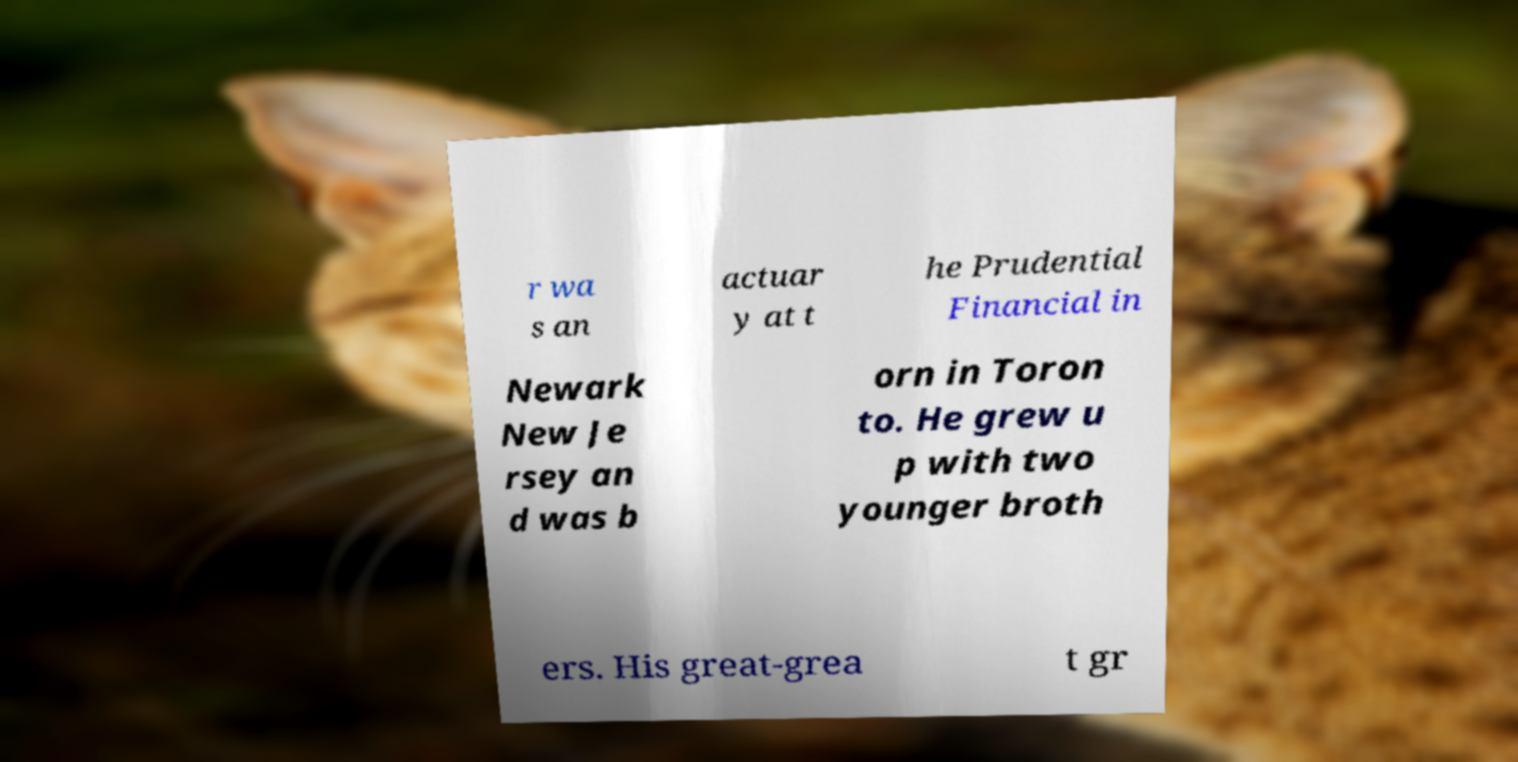Could you extract and type out the text from this image? r wa s an actuar y at t he Prudential Financial in Newark New Je rsey an d was b orn in Toron to. He grew u p with two younger broth ers. His great-grea t gr 